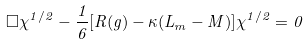Convert formula to latex. <formula><loc_0><loc_0><loc_500><loc_500>\Box \chi ^ { 1 / 2 } - \frac { 1 } { 6 } [ R ( g ) - \kappa ( L _ { m } - M ) ] \chi ^ { 1 / 2 } = 0</formula> 